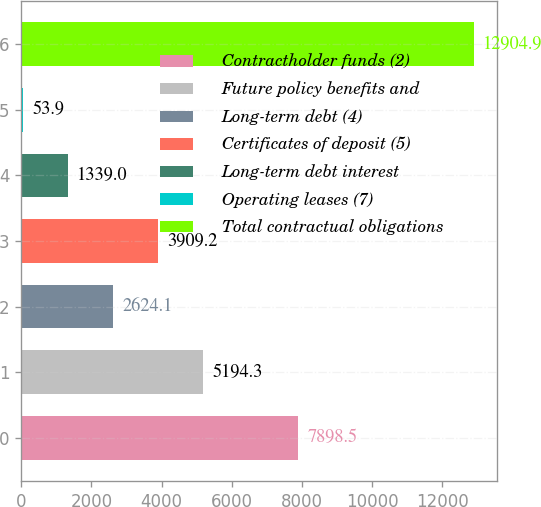Convert chart to OTSL. <chart><loc_0><loc_0><loc_500><loc_500><bar_chart><fcel>Contractholder funds (2)<fcel>Future policy benefits and<fcel>Long-term debt (4)<fcel>Certificates of deposit (5)<fcel>Long-term debt interest<fcel>Operating leases (7)<fcel>Total contractual obligations<nl><fcel>7898.5<fcel>5194.3<fcel>2624.1<fcel>3909.2<fcel>1339<fcel>53.9<fcel>12904.9<nl></chart> 